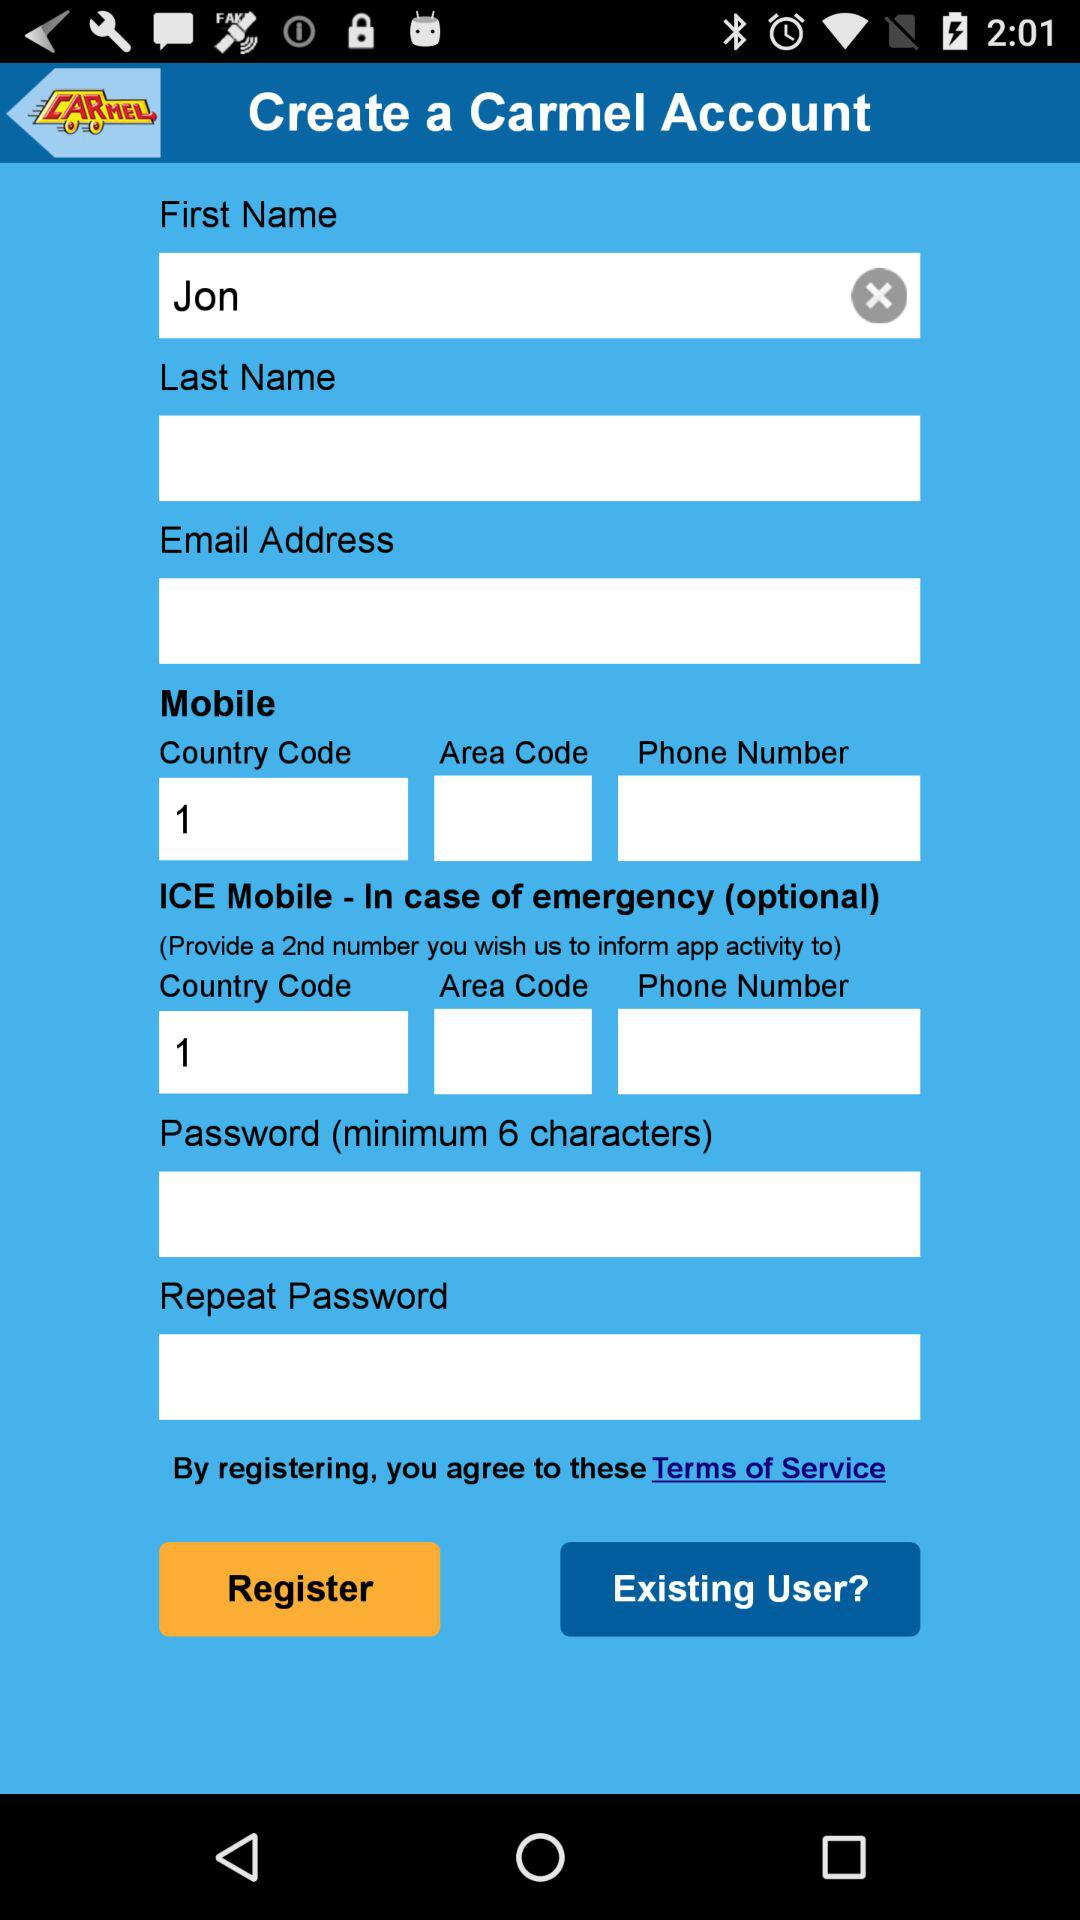In which region of the country is the area code?
When the provided information is insufficient, respond with <no answer>. <no answer> 